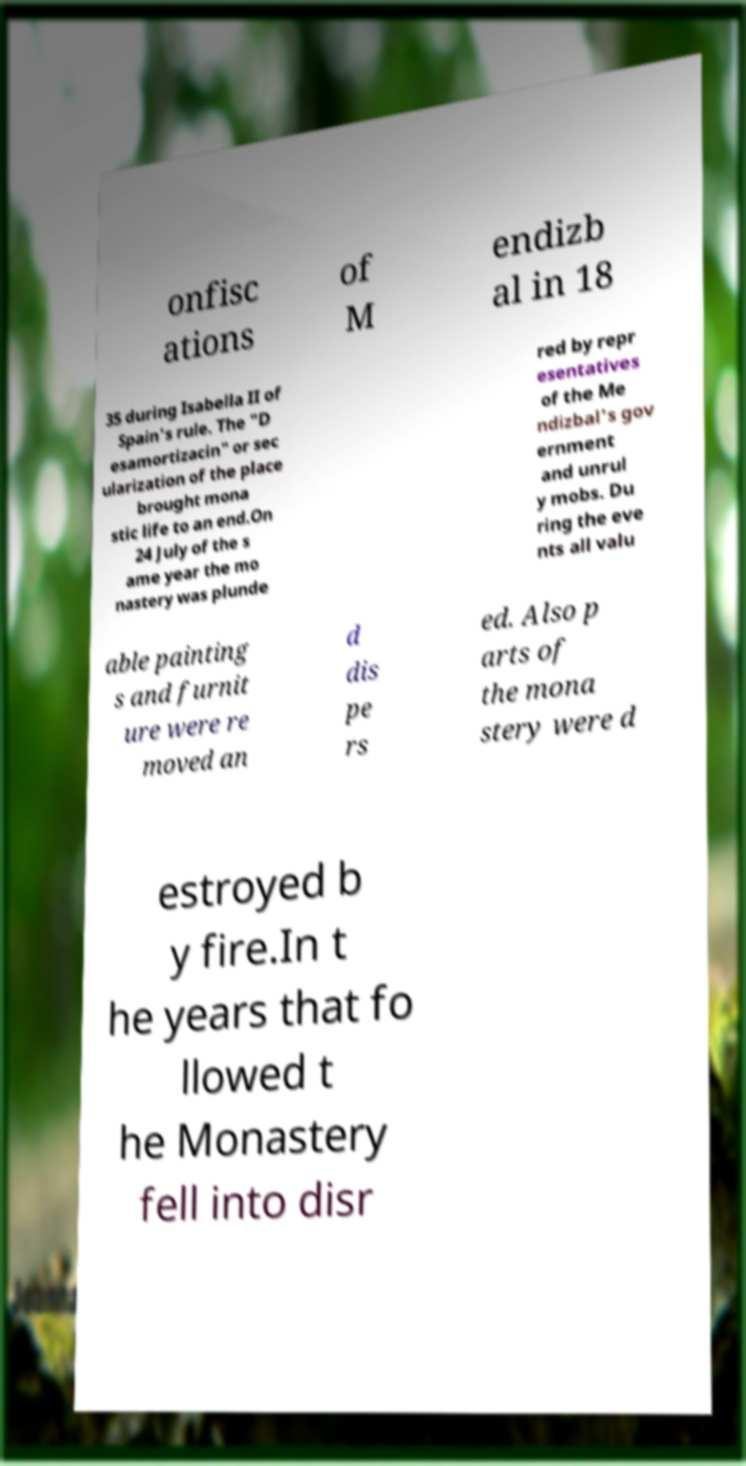Can you read and provide the text displayed in the image?This photo seems to have some interesting text. Can you extract and type it out for me? onfisc ations of M endizb al in 18 35 during Isabella II of Spain's rule. The "D esamortizacin" or sec ularization of the place brought mona stic life to an end.On 24 July of the s ame year the mo nastery was plunde red by repr esentatives of the Me ndizbal's gov ernment and unrul y mobs. Du ring the eve nts all valu able painting s and furnit ure were re moved an d dis pe rs ed. Also p arts of the mona stery were d estroyed b y fire.In t he years that fo llowed t he Monastery fell into disr 